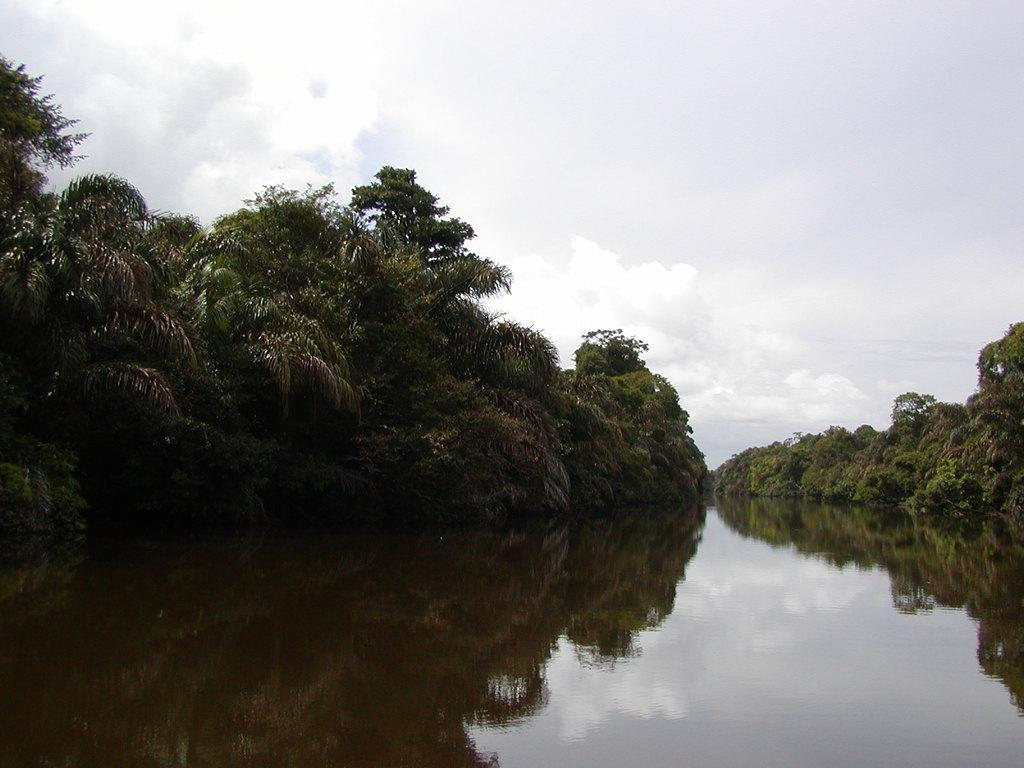What type of vegetation can be seen in the image? There are trees in the image. What is visible at the bottom of the image? There is water visible at the bottom of the image. What is visible at the top of the image? The sky is visible at the top of the image. What can be seen in the sky? Clouds are present in the sky. What type of company is conducting a meeting near the trees in the image? There is no company or meeting present in the image; it only features trees, water, and the sky. What type of lamp is hanging from the clouds in the image? There is no lamp present in the image; it only features trees, water, and the sky. 